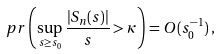<formula> <loc_0><loc_0><loc_500><loc_500>\ p r \left ( \sup _ { s \geq s _ { 0 } } \frac { | S _ { n } ( s ) | } { s } > \kappa \right ) = O ( s _ { 0 } ^ { - 1 } ) \, ,</formula> 